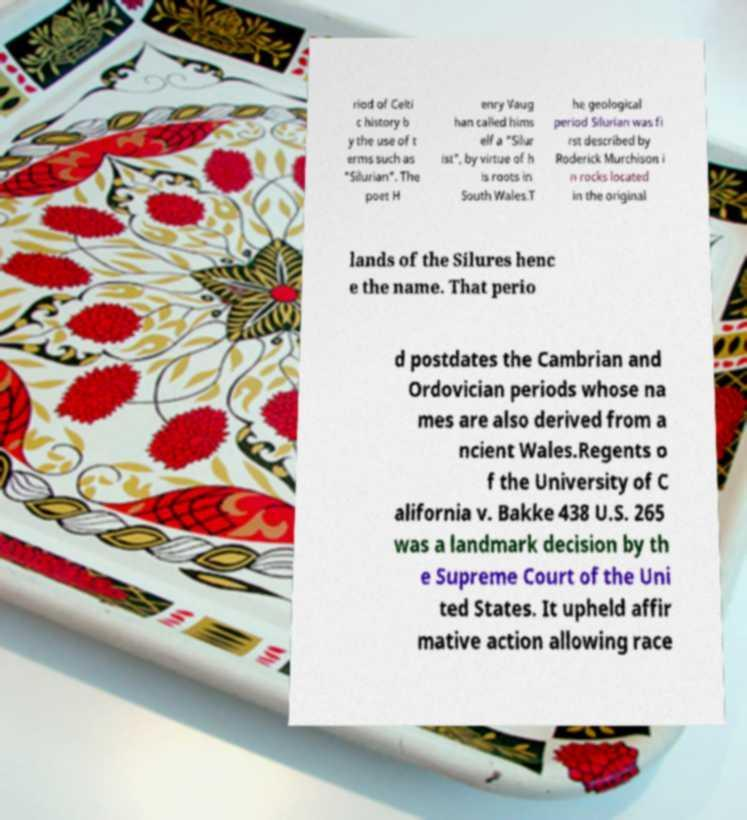Please identify and transcribe the text found in this image. riod of Celti c history b y the use of t erms such as "Silurian". The poet H enry Vaug han called hims elf a "Silur ist", by virtue of h is roots in South Wales.T he geological period Silurian was fi rst described by Roderick Murchison i n rocks located in the original lands of the Silures henc e the name. That perio d postdates the Cambrian and Ordovician periods whose na mes are also derived from a ncient Wales.Regents o f the University of C alifornia v. Bakke 438 U.S. 265 was a landmark decision by th e Supreme Court of the Uni ted States. It upheld affir mative action allowing race 